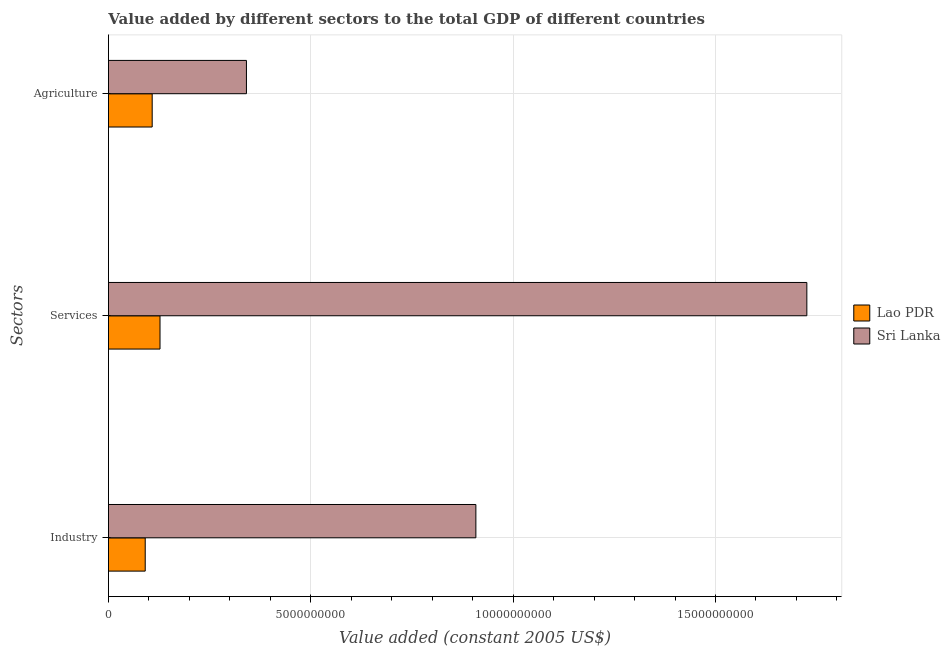How many different coloured bars are there?
Your response must be concise. 2. How many groups of bars are there?
Provide a succinct answer. 3. Are the number of bars per tick equal to the number of legend labels?
Provide a succinct answer. Yes. Are the number of bars on each tick of the Y-axis equal?
Offer a very short reply. Yes. How many bars are there on the 3rd tick from the bottom?
Make the answer very short. 2. What is the label of the 3rd group of bars from the top?
Your answer should be compact. Industry. What is the value added by services in Sri Lanka?
Make the answer very short. 1.73e+1. Across all countries, what is the maximum value added by agricultural sector?
Ensure brevity in your answer.  3.41e+09. Across all countries, what is the minimum value added by industrial sector?
Your answer should be very brief. 9.09e+08. In which country was the value added by agricultural sector maximum?
Your answer should be very brief. Sri Lanka. In which country was the value added by agricultural sector minimum?
Provide a short and direct response. Lao PDR. What is the total value added by services in the graph?
Make the answer very short. 1.85e+1. What is the difference between the value added by industrial sector in Sri Lanka and that in Lao PDR?
Give a very brief answer. 8.17e+09. What is the difference between the value added by agricultural sector in Sri Lanka and the value added by industrial sector in Lao PDR?
Your response must be concise. 2.50e+09. What is the average value added by industrial sector per country?
Provide a short and direct response. 4.99e+09. What is the difference between the value added by services and value added by industrial sector in Lao PDR?
Offer a very short reply. 3.66e+08. What is the ratio of the value added by services in Lao PDR to that in Sri Lanka?
Keep it short and to the point. 0.07. Is the value added by industrial sector in Sri Lanka less than that in Lao PDR?
Provide a short and direct response. No. Is the difference between the value added by industrial sector in Lao PDR and Sri Lanka greater than the difference between the value added by agricultural sector in Lao PDR and Sri Lanka?
Ensure brevity in your answer.  No. What is the difference between the highest and the second highest value added by agricultural sector?
Your answer should be very brief. 2.33e+09. What is the difference between the highest and the lowest value added by services?
Offer a terse response. 1.60e+1. In how many countries, is the value added by industrial sector greater than the average value added by industrial sector taken over all countries?
Your response must be concise. 1. Is the sum of the value added by agricultural sector in Lao PDR and Sri Lanka greater than the maximum value added by services across all countries?
Make the answer very short. No. What does the 2nd bar from the top in Industry represents?
Give a very brief answer. Lao PDR. What does the 1st bar from the bottom in Services represents?
Give a very brief answer. Lao PDR. What is the difference between two consecutive major ticks on the X-axis?
Offer a terse response. 5.00e+09. Are the values on the major ticks of X-axis written in scientific E-notation?
Make the answer very short. No. Does the graph contain grids?
Give a very brief answer. Yes. Where does the legend appear in the graph?
Offer a terse response. Center right. What is the title of the graph?
Your answer should be very brief. Value added by different sectors to the total GDP of different countries. Does "Low & middle income" appear as one of the legend labels in the graph?
Your answer should be compact. No. What is the label or title of the X-axis?
Your answer should be compact. Value added (constant 2005 US$). What is the label or title of the Y-axis?
Offer a terse response. Sectors. What is the Value added (constant 2005 US$) in Lao PDR in Industry?
Give a very brief answer. 9.09e+08. What is the Value added (constant 2005 US$) of Sri Lanka in Industry?
Your response must be concise. 9.08e+09. What is the Value added (constant 2005 US$) in Lao PDR in Services?
Offer a terse response. 1.27e+09. What is the Value added (constant 2005 US$) of Sri Lanka in Services?
Give a very brief answer. 1.73e+1. What is the Value added (constant 2005 US$) of Lao PDR in Agriculture?
Your answer should be very brief. 1.08e+09. What is the Value added (constant 2005 US$) in Sri Lanka in Agriculture?
Keep it short and to the point. 3.41e+09. Across all Sectors, what is the maximum Value added (constant 2005 US$) of Lao PDR?
Keep it short and to the point. 1.27e+09. Across all Sectors, what is the maximum Value added (constant 2005 US$) of Sri Lanka?
Ensure brevity in your answer.  1.73e+1. Across all Sectors, what is the minimum Value added (constant 2005 US$) of Lao PDR?
Your response must be concise. 9.09e+08. Across all Sectors, what is the minimum Value added (constant 2005 US$) in Sri Lanka?
Keep it short and to the point. 3.41e+09. What is the total Value added (constant 2005 US$) of Lao PDR in the graph?
Ensure brevity in your answer.  3.26e+09. What is the total Value added (constant 2005 US$) in Sri Lanka in the graph?
Make the answer very short. 2.97e+1. What is the difference between the Value added (constant 2005 US$) in Lao PDR in Industry and that in Services?
Ensure brevity in your answer.  -3.66e+08. What is the difference between the Value added (constant 2005 US$) of Sri Lanka in Industry and that in Services?
Your answer should be compact. -8.18e+09. What is the difference between the Value added (constant 2005 US$) in Lao PDR in Industry and that in Agriculture?
Keep it short and to the point. -1.72e+08. What is the difference between the Value added (constant 2005 US$) in Sri Lanka in Industry and that in Agriculture?
Provide a succinct answer. 5.67e+09. What is the difference between the Value added (constant 2005 US$) of Lao PDR in Services and that in Agriculture?
Your answer should be compact. 1.93e+08. What is the difference between the Value added (constant 2005 US$) of Sri Lanka in Services and that in Agriculture?
Offer a terse response. 1.38e+1. What is the difference between the Value added (constant 2005 US$) in Lao PDR in Industry and the Value added (constant 2005 US$) in Sri Lanka in Services?
Offer a very short reply. -1.63e+1. What is the difference between the Value added (constant 2005 US$) of Lao PDR in Industry and the Value added (constant 2005 US$) of Sri Lanka in Agriculture?
Provide a short and direct response. -2.50e+09. What is the difference between the Value added (constant 2005 US$) of Lao PDR in Services and the Value added (constant 2005 US$) of Sri Lanka in Agriculture?
Your answer should be very brief. -2.14e+09. What is the average Value added (constant 2005 US$) in Lao PDR per Sectors?
Offer a terse response. 1.09e+09. What is the average Value added (constant 2005 US$) in Sri Lanka per Sectors?
Your response must be concise. 9.92e+09. What is the difference between the Value added (constant 2005 US$) in Lao PDR and Value added (constant 2005 US$) in Sri Lanka in Industry?
Your response must be concise. -8.17e+09. What is the difference between the Value added (constant 2005 US$) of Lao PDR and Value added (constant 2005 US$) of Sri Lanka in Services?
Your response must be concise. -1.60e+1. What is the difference between the Value added (constant 2005 US$) of Lao PDR and Value added (constant 2005 US$) of Sri Lanka in Agriculture?
Make the answer very short. -2.33e+09. What is the ratio of the Value added (constant 2005 US$) in Lao PDR in Industry to that in Services?
Offer a very short reply. 0.71. What is the ratio of the Value added (constant 2005 US$) of Sri Lanka in Industry to that in Services?
Your answer should be very brief. 0.53. What is the ratio of the Value added (constant 2005 US$) in Lao PDR in Industry to that in Agriculture?
Offer a very short reply. 0.84. What is the ratio of the Value added (constant 2005 US$) in Sri Lanka in Industry to that in Agriculture?
Ensure brevity in your answer.  2.66. What is the ratio of the Value added (constant 2005 US$) of Lao PDR in Services to that in Agriculture?
Provide a succinct answer. 1.18. What is the ratio of the Value added (constant 2005 US$) in Sri Lanka in Services to that in Agriculture?
Provide a short and direct response. 5.06. What is the difference between the highest and the second highest Value added (constant 2005 US$) in Lao PDR?
Your response must be concise. 1.93e+08. What is the difference between the highest and the second highest Value added (constant 2005 US$) of Sri Lanka?
Your response must be concise. 8.18e+09. What is the difference between the highest and the lowest Value added (constant 2005 US$) of Lao PDR?
Ensure brevity in your answer.  3.66e+08. What is the difference between the highest and the lowest Value added (constant 2005 US$) in Sri Lanka?
Ensure brevity in your answer.  1.38e+1. 